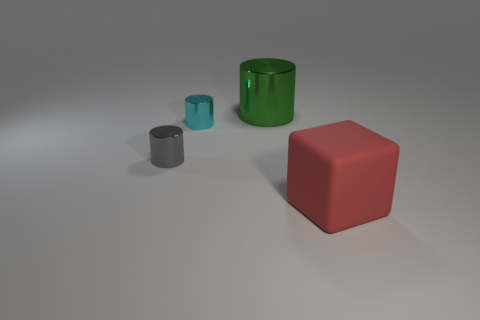Does the image seem to be part of a larger story or theme? The image could represent a scene of simplicity and minimalism, focusing on basic geometric shapes and colors, perhaps as a study of forms and hues in a controlled setting. 